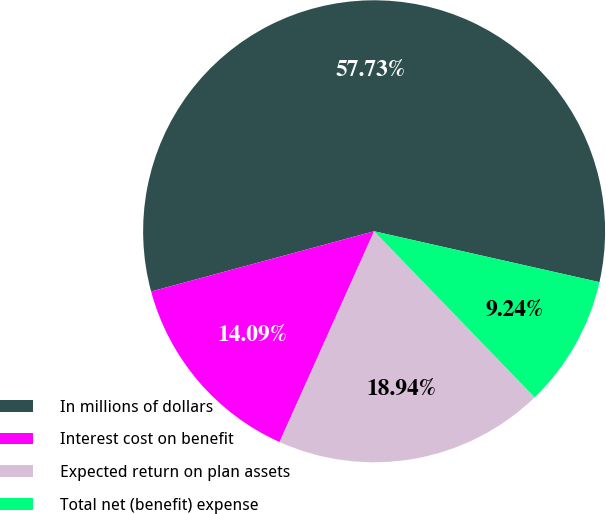Convert chart. <chart><loc_0><loc_0><loc_500><loc_500><pie_chart><fcel>In millions of dollars<fcel>Interest cost on benefit<fcel>Expected return on plan assets<fcel>Total net (benefit) expense<nl><fcel>57.74%<fcel>14.09%<fcel>18.94%<fcel>9.24%<nl></chart> 